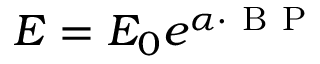Convert formula to latex. <formula><loc_0><loc_0><loc_500><loc_500>E = E _ { 0 } e ^ { \alpha \cdot B P }</formula> 